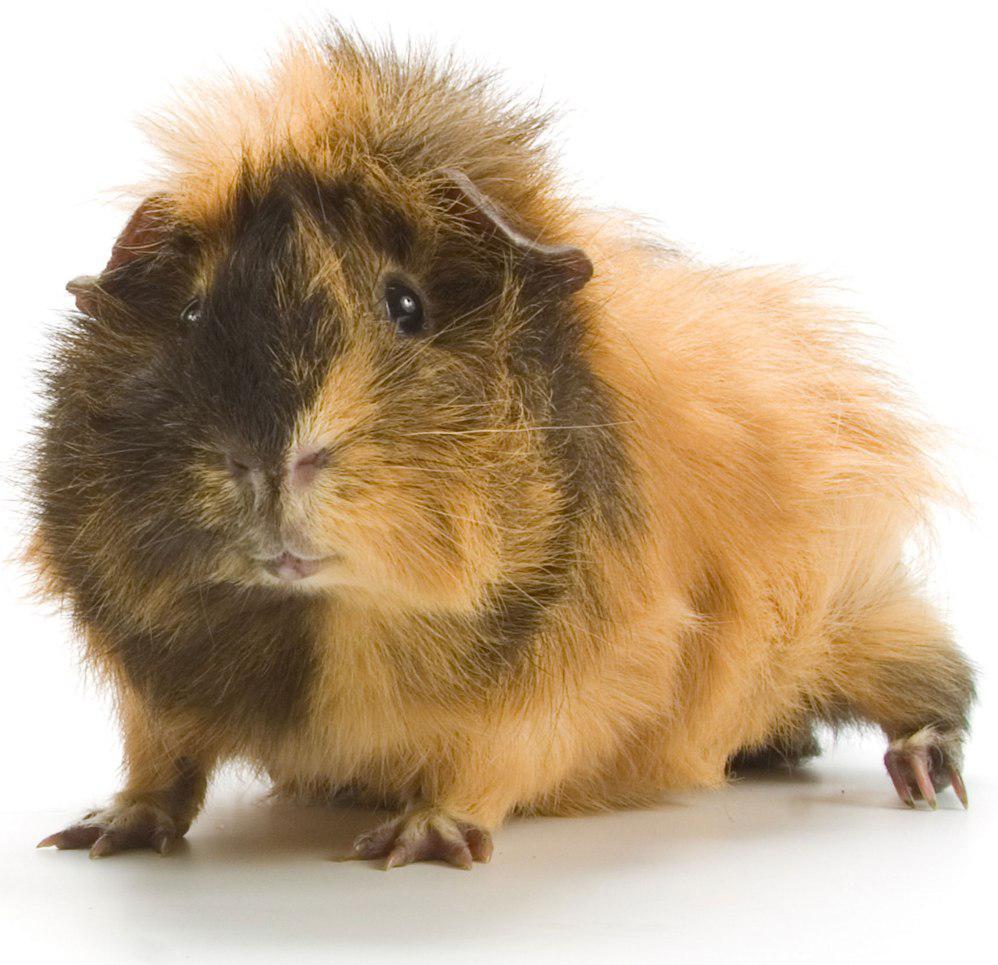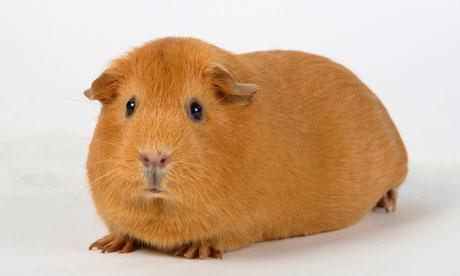The first image is the image on the left, the second image is the image on the right. Given the left and right images, does the statement "There are two hamsters lying down." hold true? Answer yes or no. Yes. The first image is the image on the left, the second image is the image on the right. Given the left and right images, does the statement "Each image contains a single guinea pig, and the one on the right has all golden-orange fur." hold true? Answer yes or no. Yes. 